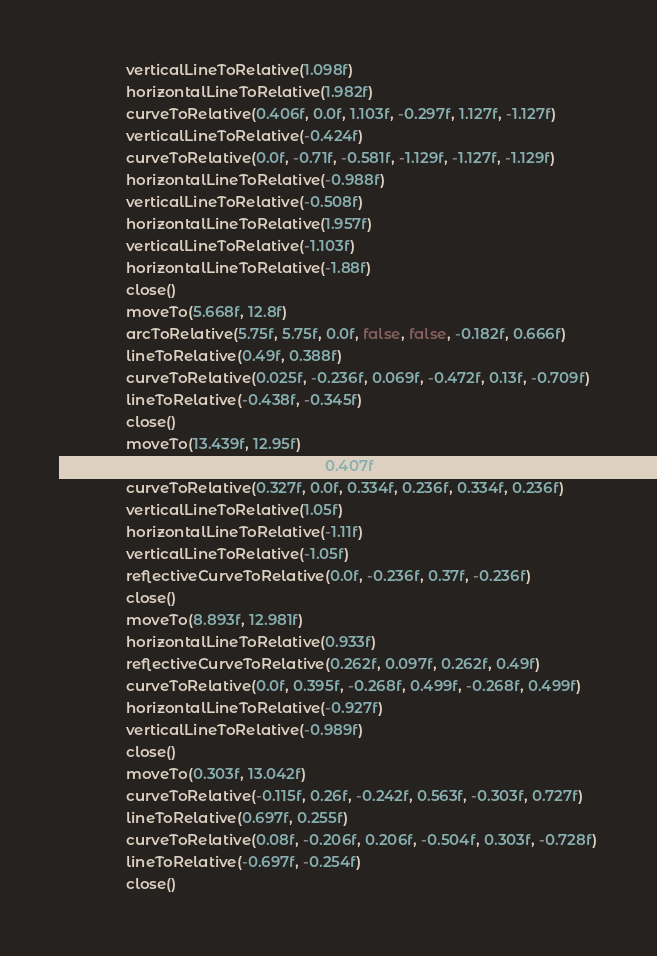Convert code to text. <code><loc_0><loc_0><loc_500><loc_500><_Kotlin_>                verticalLineToRelative(1.098f)
                horizontalLineToRelative(1.982f)
                curveToRelative(0.406f, 0.0f, 1.103f, -0.297f, 1.127f, -1.127f)
                verticalLineToRelative(-0.424f)
                curveToRelative(0.0f, -0.71f, -0.581f, -1.129f, -1.127f, -1.129f)
                horizontalLineToRelative(-0.988f)
                verticalLineToRelative(-0.508f)
                horizontalLineToRelative(1.957f)
                verticalLineToRelative(-1.103f)
                horizontalLineToRelative(-1.88f)
                close()
                moveTo(5.668f, 12.8f)
                arcToRelative(5.75f, 5.75f, 0.0f, false, false, -0.182f, 0.666f)
                lineToRelative(0.49f, 0.388f)
                curveToRelative(0.025f, -0.236f, 0.069f, -0.472f, 0.13f, -0.709f)
                lineToRelative(-0.438f, -0.345f)
                close()
                moveTo(13.439f, 12.95f)
                horizontalLineToRelative(0.407f)
                curveToRelative(0.327f, 0.0f, 0.334f, 0.236f, 0.334f, 0.236f)
                verticalLineToRelative(1.05f)
                horizontalLineToRelative(-1.11f)
                verticalLineToRelative(-1.05f)
                reflectiveCurveToRelative(0.0f, -0.236f, 0.37f, -0.236f)
                close()
                moveTo(8.893f, 12.981f)
                horizontalLineToRelative(0.933f)
                reflectiveCurveToRelative(0.262f, 0.097f, 0.262f, 0.49f)
                curveToRelative(0.0f, 0.395f, -0.268f, 0.499f, -0.268f, 0.499f)
                horizontalLineToRelative(-0.927f)
                verticalLineToRelative(-0.989f)
                close()
                moveTo(0.303f, 13.042f)
                curveToRelative(-0.115f, 0.26f, -0.242f, 0.563f, -0.303f, 0.727f)
                lineToRelative(0.697f, 0.255f)
                curveToRelative(0.08f, -0.206f, 0.206f, -0.504f, 0.303f, -0.728f)
                lineToRelative(-0.697f, -0.254f)
                close()</code> 